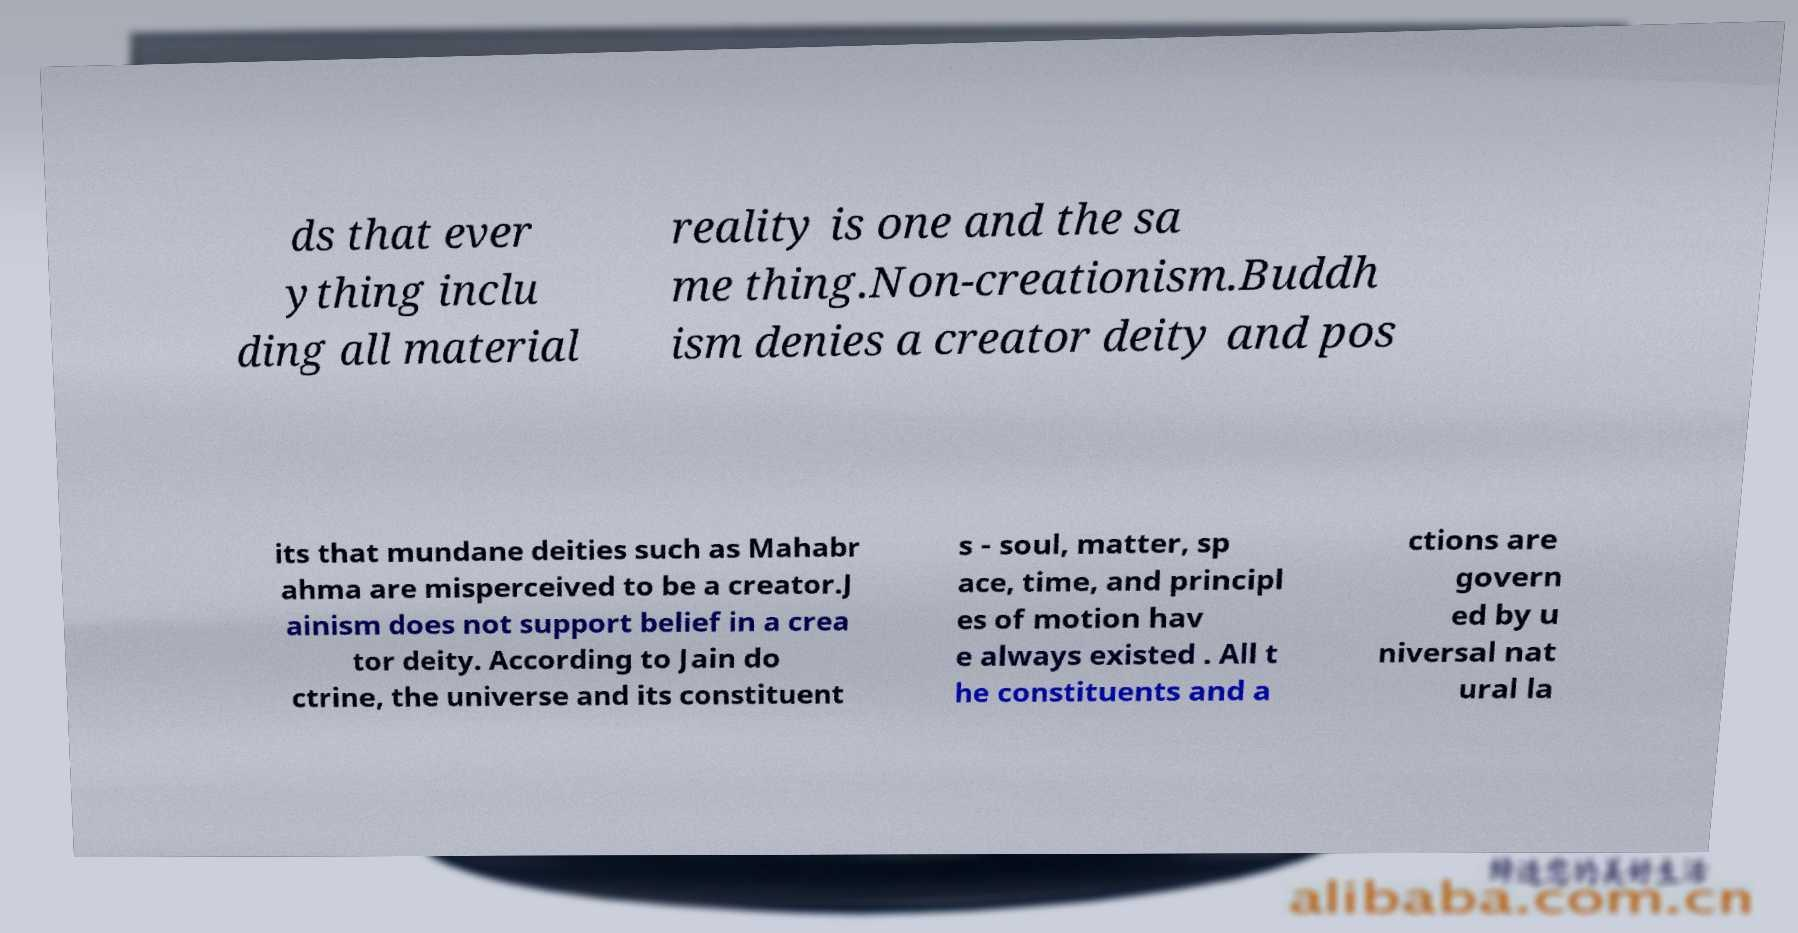For documentation purposes, I need the text within this image transcribed. Could you provide that? ds that ever ything inclu ding all material reality is one and the sa me thing.Non-creationism.Buddh ism denies a creator deity and pos its that mundane deities such as Mahabr ahma are misperceived to be a creator.J ainism does not support belief in a crea tor deity. According to Jain do ctrine, the universe and its constituent s - soul, matter, sp ace, time, and principl es of motion hav e always existed . All t he constituents and a ctions are govern ed by u niversal nat ural la 